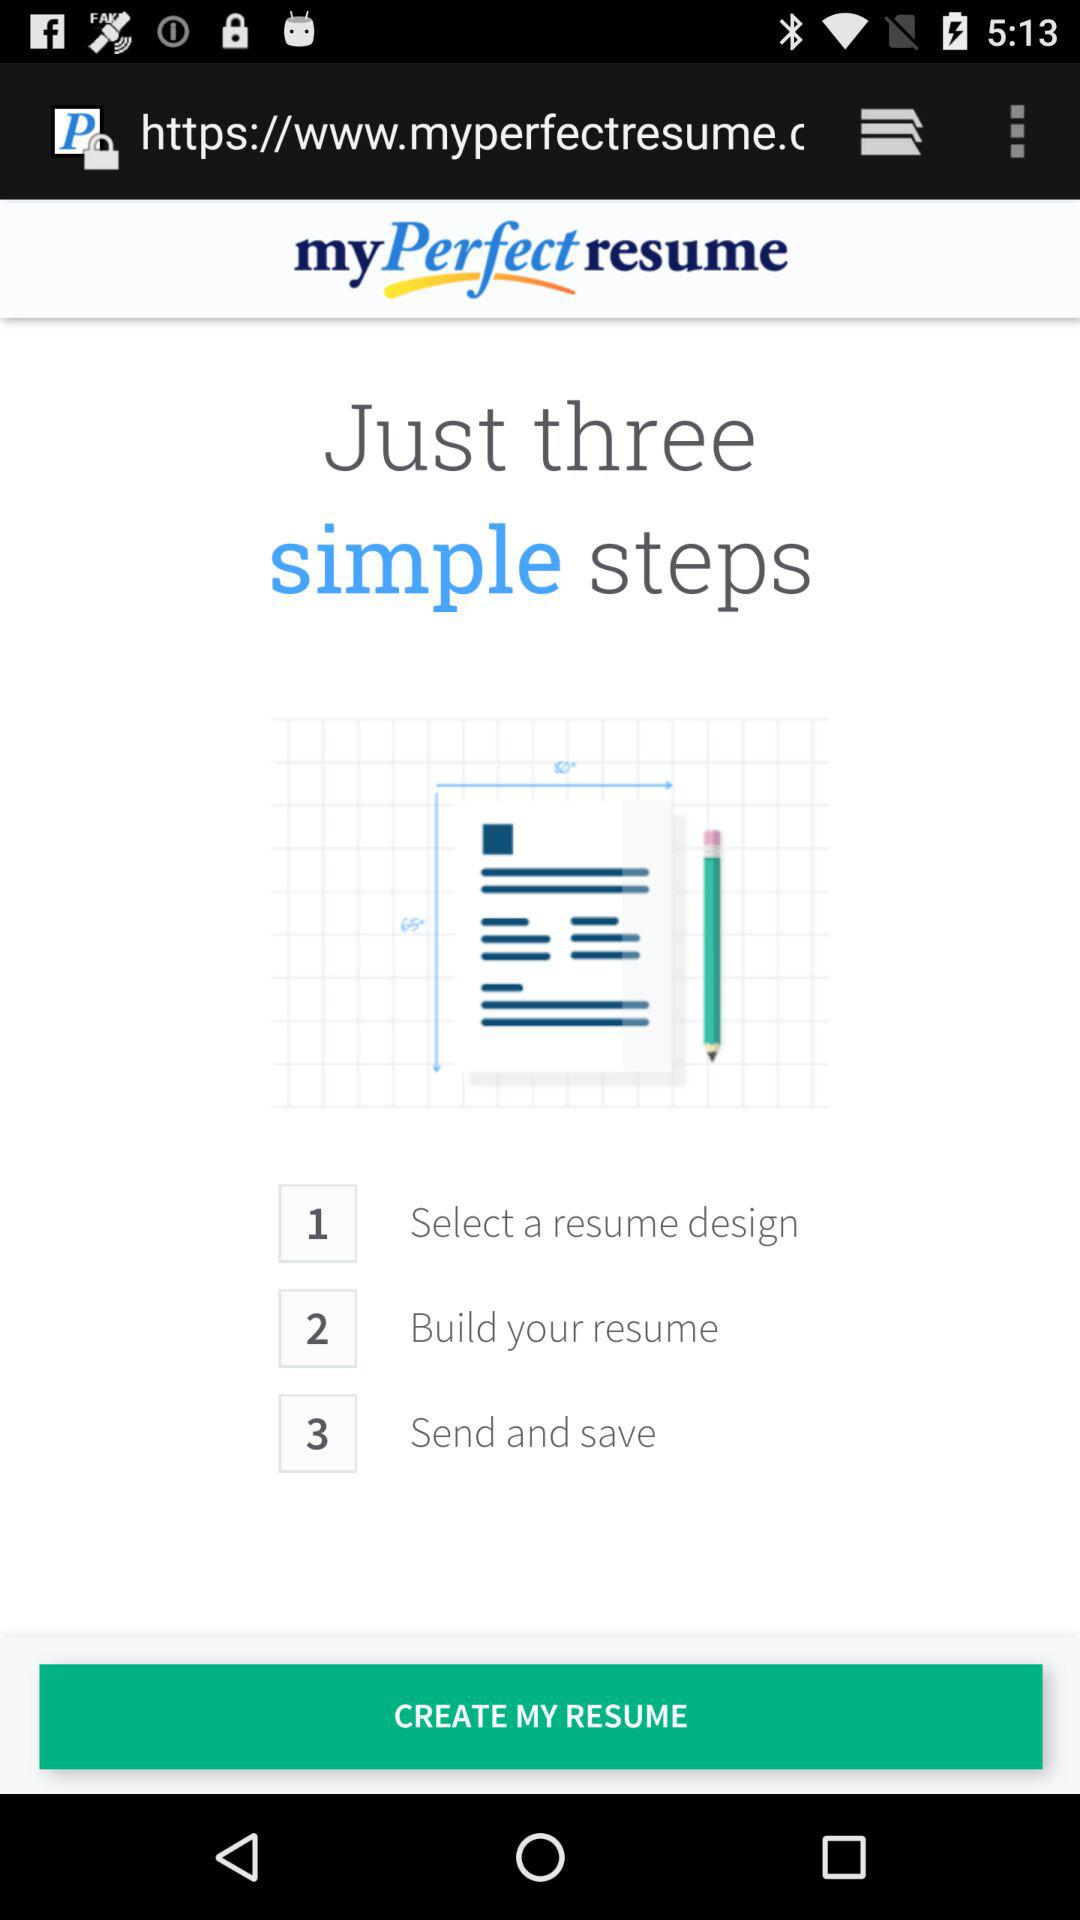How many steps are there in the process of creating a resume with myPerfect resume?
Answer the question using a single word or phrase. 3 